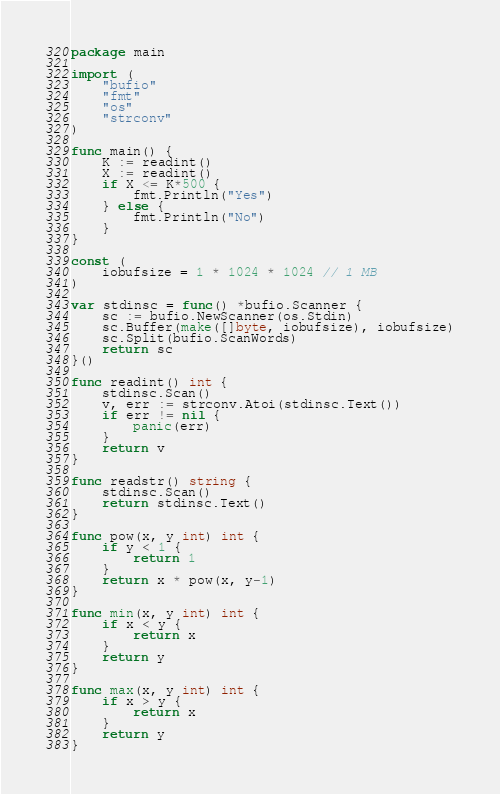<code> <loc_0><loc_0><loc_500><loc_500><_Go_>package main

import (
	"bufio"
	"fmt"
	"os"
	"strconv"
)

func main() {
	K := readint()
	X := readint()
	if X <= K*500 {
		fmt.Println("Yes")
	} else {
		fmt.Println("No")
	}
}

const (
	iobufsize = 1 * 1024 * 1024 // 1 MB
)

var stdinsc = func() *bufio.Scanner {
	sc := bufio.NewScanner(os.Stdin)
	sc.Buffer(make([]byte, iobufsize), iobufsize)
	sc.Split(bufio.ScanWords)
	return sc
}()

func readint() int {
	stdinsc.Scan()
	v, err := strconv.Atoi(stdinsc.Text())
	if err != nil {
		panic(err)
	}
	return v
}

func readstr() string {
	stdinsc.Scan()
	return stdinsc.Text()
}

func pow(x, y int) int {
	if y < 1 {
		return 1
	}
	return x * pow(x, y-1)
}

func min(x, y int) int {
	if x < y {
		return x
	}
	return y
}

func max(x, y int) int {
	if x > y {
		return x
	}
	return y
}
</code> 